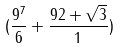<formula> <loc_0><loc_0><loc_500><loc_500>( \frac { 9 ^ { 7 } } { 6 } + \frac { 9 2 + \sqrt { 3 } } { 1 } )</formula> 